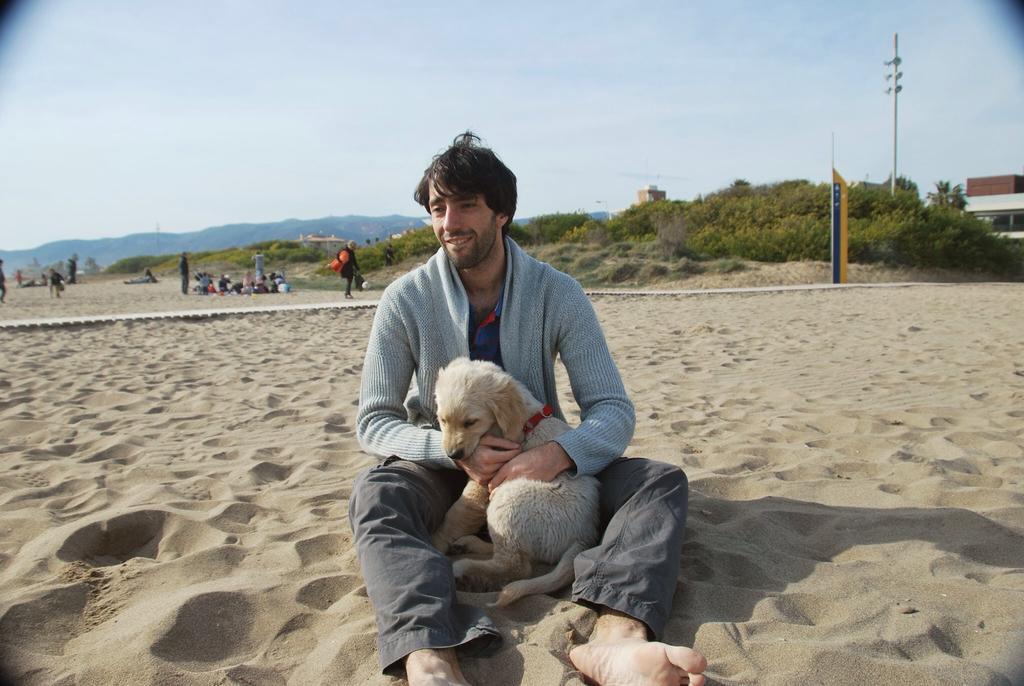How would you summarize this image in a sentence or two? In this image I can see a man is sitting and holding a dog. In the background I can see few more people, trees, a building, a pole and clear view of sky. I can also see smile on his face. 